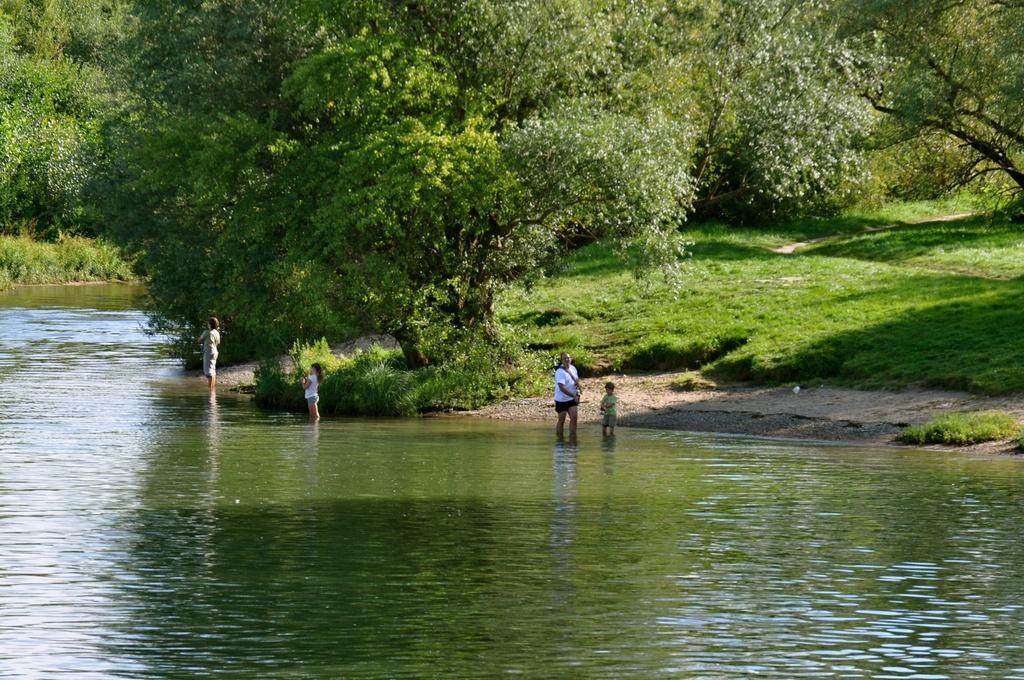What are the people in the image doing? The people in the image are standing in the water. What type of vegetation can be seen in the image? Trees are visible in the image. What is on the ground in the image? Grass is present on the ground. What type of lumber is being used to build the structure in the image? There is no structure or lumber present in the image; it features people standing in the water with trees and grass in the background. 